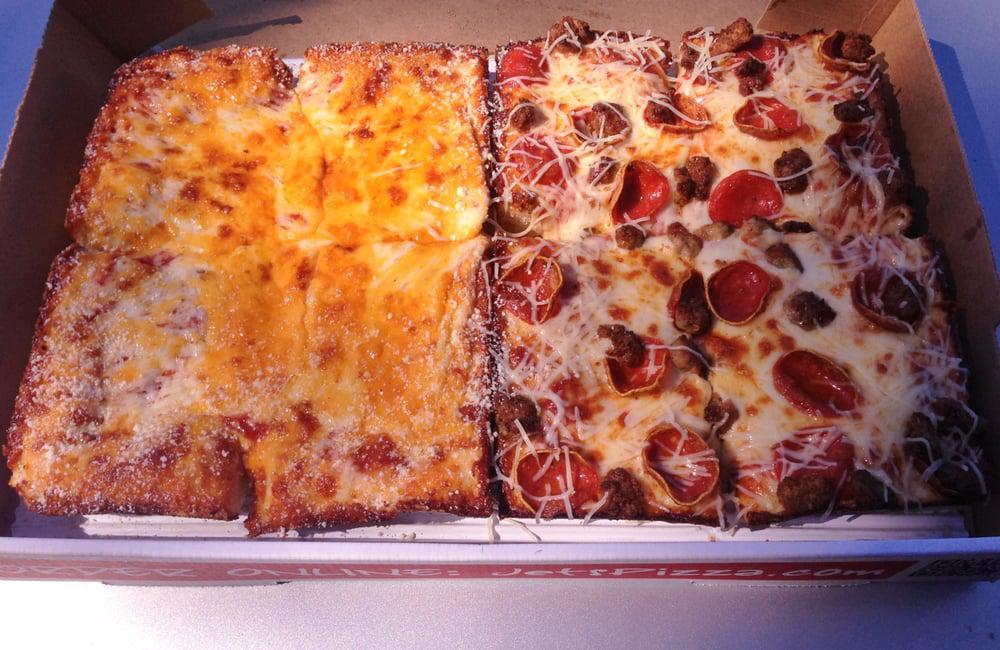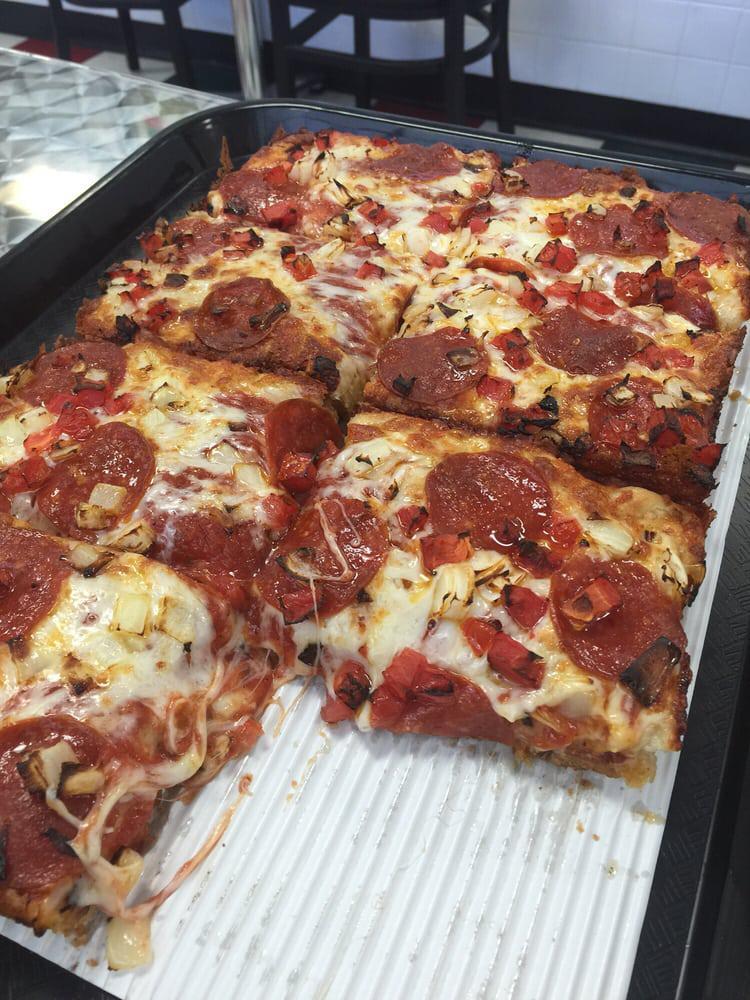The first image is the image on the left, the second image is the image on the right. Analyze the images presented: Is the assertion "No image shows a round pizza or triangular slice, and one image shows less than a complete rectangular pizza." valid? Answer yes or no. Yes. The first image is the image on the left, the second image is the image on the right. Examine the images to the left and right. Is the description "The pizzas in both images are not circles, but are shaped like rectangles instead." accurate? Answer yes or no. Yes. 